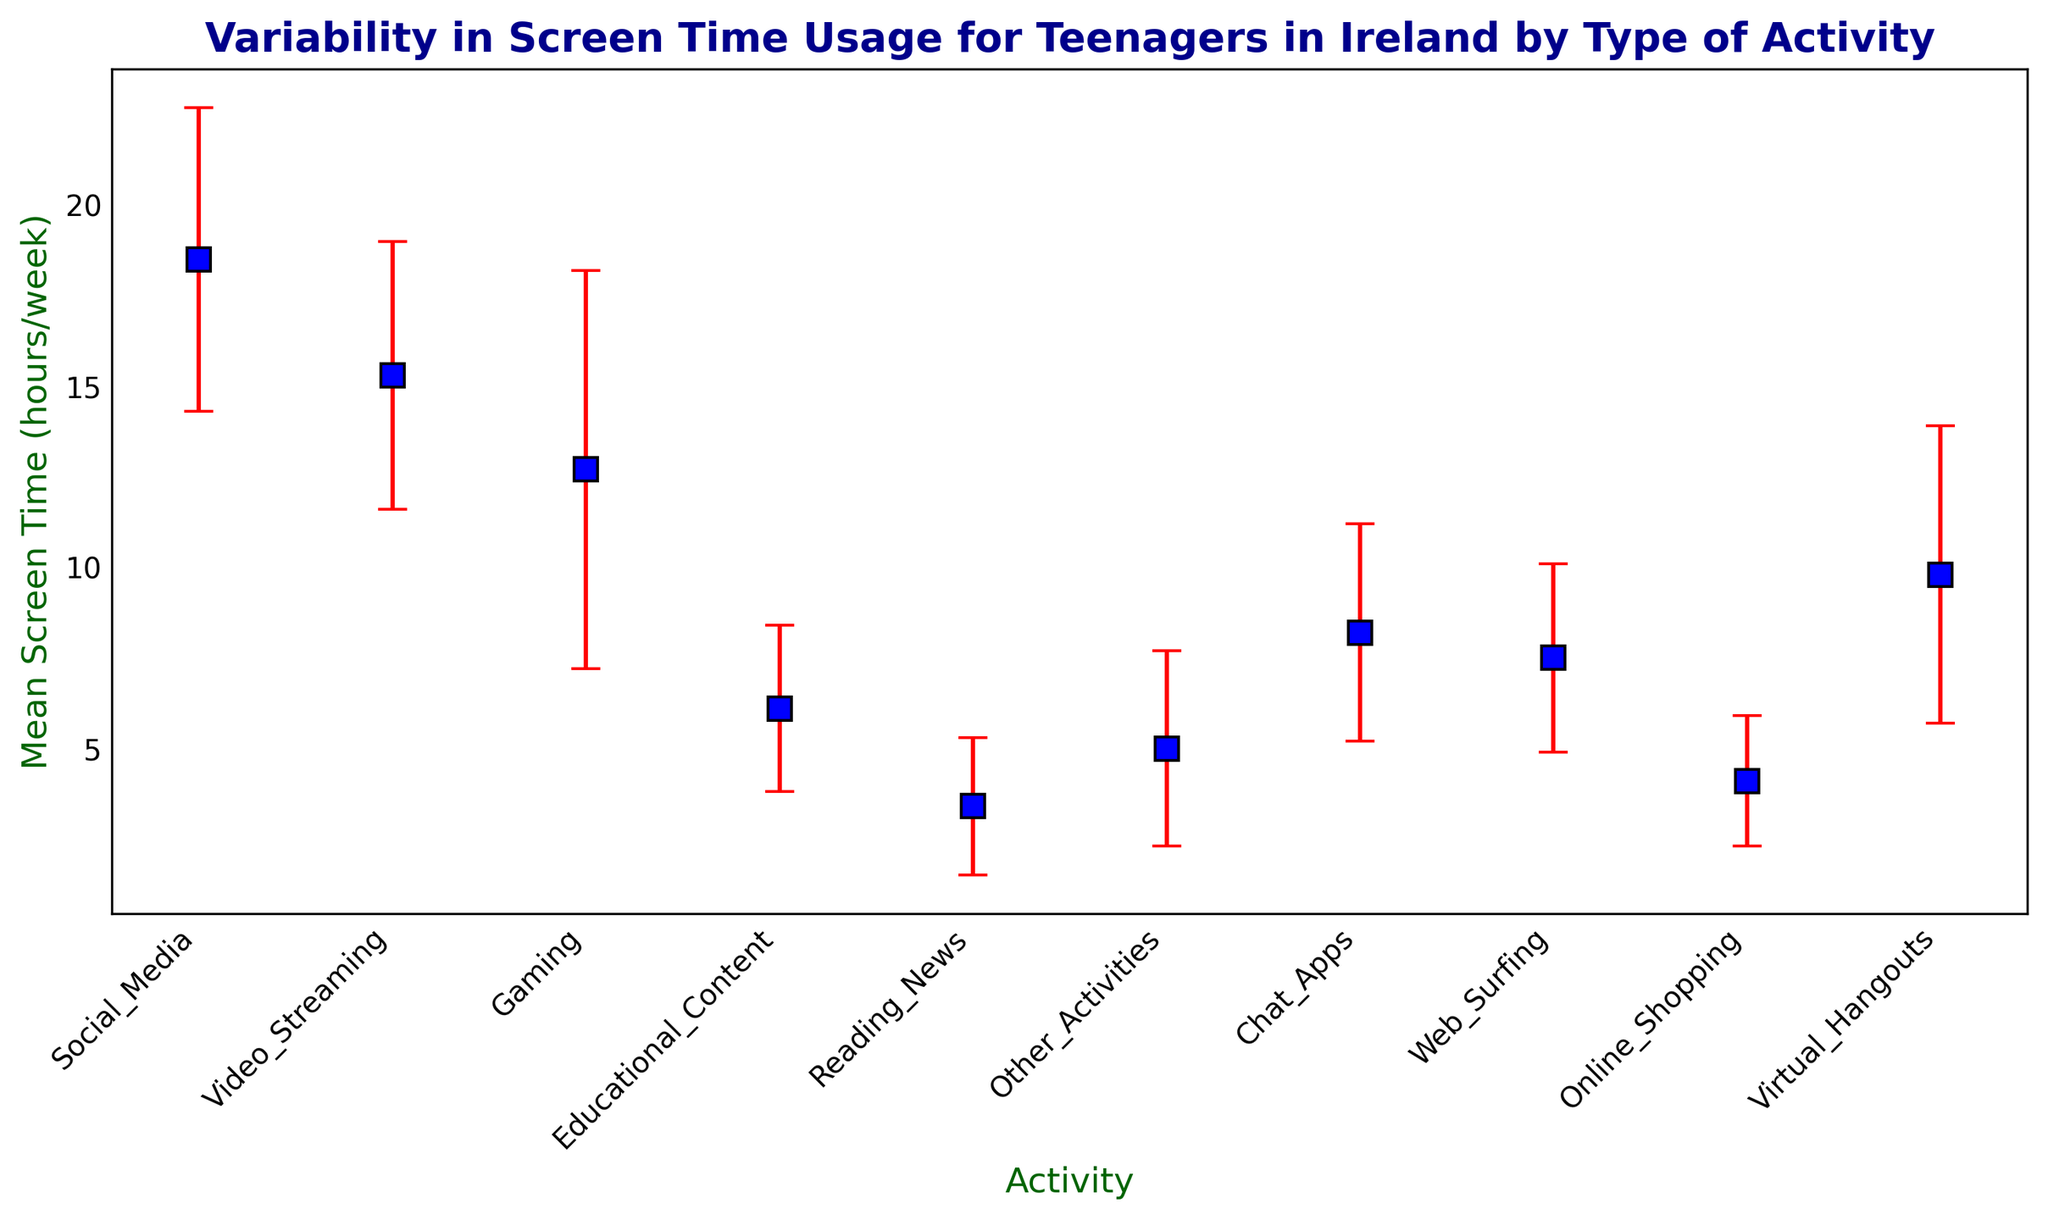What activity has the highest mean screen time? The figure shows that Social_Media has the highest mean screen time with a value of 18.5 hours/week.
Answer: Social_Media What is the difference in mean screen time between Social_Media and Online_Shopping? The figure shows Social_Media has a mean screen time of 18.5 hours/week and Online_Shopping has a mean screen time of 4.1 hours/week. The difference is 18.5 - 4.1.
Answer: 14.4 Which activity has the largest variability in screen time usage? The activities with the largest variability have the largest error bars. Gaming has the largest error bar with a standard deviation of 5.5 hours/week.
Answer: Gaming What is the mean screen time for educational content? The figure shows that Educational_Content has a mean screen time of 6.1 hours/week.
Answer: 6.1 Compare the mean screen time for Gaming and Virtual_Hangouts. Which is higher? According to the figure, Virtual_Hangouts has a mean screen time of 9.8 hours/week and Gaming has a mean screen time of 12.7 hours/week. Gaming is higher.
Answer: Gaming What is the range of mean screen time values depicted in the figure? The range can be found by the difference between the highest and lowest mean screen time. Social_Media has the highest mean screen time (18.5 hours/week) and Reading_News has the lowest (3.4 hours/week). The range is 18.5 - 3.4.
Answer: 15.1 Which activity has less variability: Video_Streaming or Chat_Apps? Compare the standard deviations (error bars) shown in the figure. Video_Streaming has a standard deviation of 3.7 hours/week and Chat_Apps has a standard deviation of 3.0 hours/week. Chat_Apps has less variability.
Answer: Chat_Apps What is the median mean screen time value among all activities? To find the median, list the mean screen times in order: 3.4, 4.1, 5.0, 6.1, 7.5, 8.2, 9.8, 12.7, 15.3, 18.5. The median value (middle value) for the 10 activities is the average of the 5th and 6th values: (7.5 + 8.2)/2.
Answer: 7.85 What is the total mean screen time for Social_Media, Video_Streaming, and Gaming combined? Add the mean screen times for each: 18.5 (Social_Media) + 15.3 (Video_Streaming) + 12.7 (Gaming). The total is 46.5 hours/week.
Answer: 46.5 